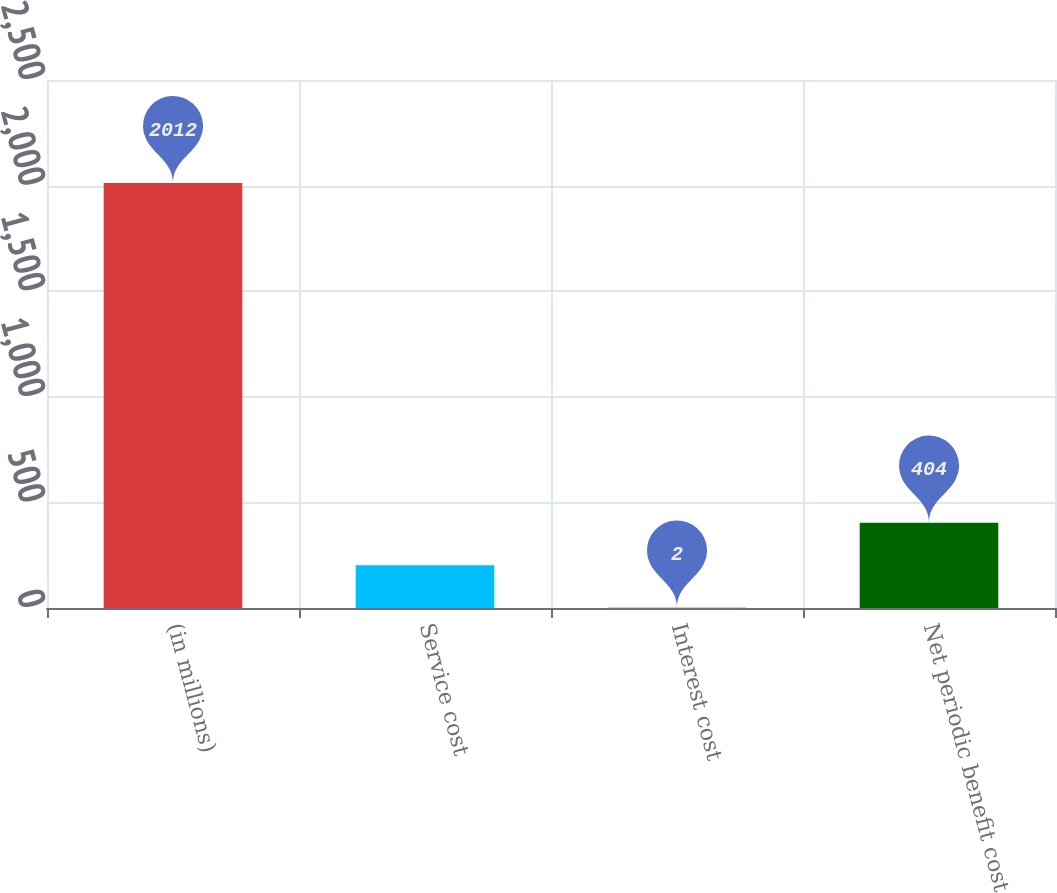Convert chart. <chart><loc_0><loc_0><loc_500><loc_500><bar_chart><fcel>(in millions)<fcel>Service cost<fcel>Interest cost<fcel>Net periodic benefit cost<nl><fcel>2012<fcel>203<fcel>2<fcel>404<nl></chart> 